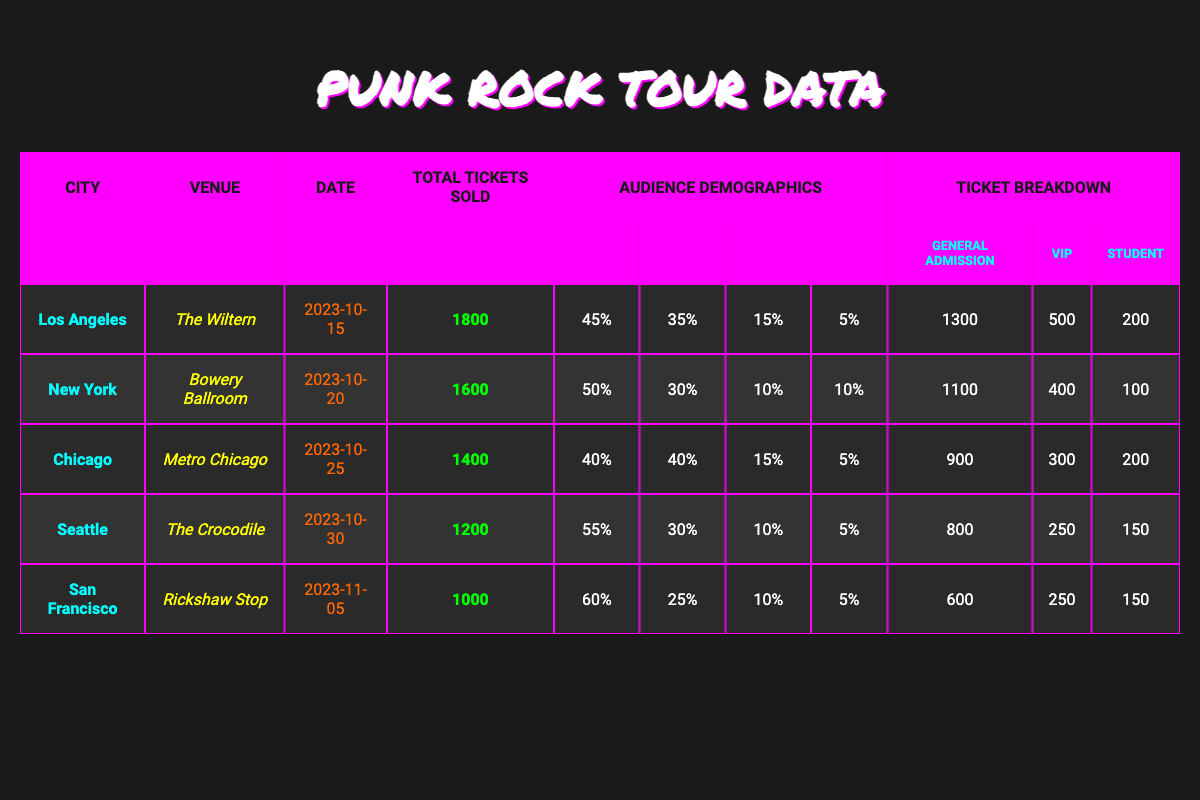What is the total number of tickets sold in Chicago? The table shows that the total tickets sold in Chicago is listed under the "Total Tickets Sold" column, which states 1400.
Answer: 1400 Which city had the highest percentage of audience aged 16-24? In the audience demographics section, Seattle has 55% in the age 16-24 category, which is the highest compared to other cities listed.
Answer: Seattle What is the gender distribution of the audience in New York? New York's audience demographics show 60% male, 35% female, and 5% other.
Answer: 60% male, 35% female, 5% other How many more general admission tickets were sold in Los Angeles compared to San Francisco? According to the ticket breakdown, Los Angeles sold 1300 general admission tickets, while San Francisco sold 600. The difference is 1300 - 600 = 700.
Answer: 700 True or False: More than half of the audience in San Francisco is aged 35 or older. The table shows 10% aged 35-44 and 5% aged 45+, making a total of 15%, which is not more than half.
Answer: False What is the average number of VIP tickets sold across all cities? The total number of VIP tickets sold across the cities is 500 (LA) + 400 (NY) + 300 (Chicago) + 250 (Seattle) + 250 (SF) = 1700. There are 5 cities, so the average is 1700/5 = 340.
Answer: 340 Which city had the lowest total tickets sold and how many were sold? The table indicates San Francisco had the lowest total tickets sold at 1000.
Answer: San Francisco, 1000 What percentage of tickets sold in Chicago were student tickets? In Chicago, 200 student tickets were sold out of 1400 total tickets. The percentage is calculated as (200/1400) * 100 = 14.29%.
Answer: 14.29% How does the audience demographic in terms of age in Seattle compare to that in New York? Seattle has 55% aged 16-24 and 30% aged 25-34, while New York has 50% aged 16-24 and 30% aged 25-34, indicating Seattle has a higher percentage of younger audience.
Answer: Seattle has a higher percentage of younger audience Which city has the highest total tickets sold and what is the number? The city with the highest total tickets sold is Los Angeles, with 1800 tickets sold.
Answer: Los Angeles, 1800 